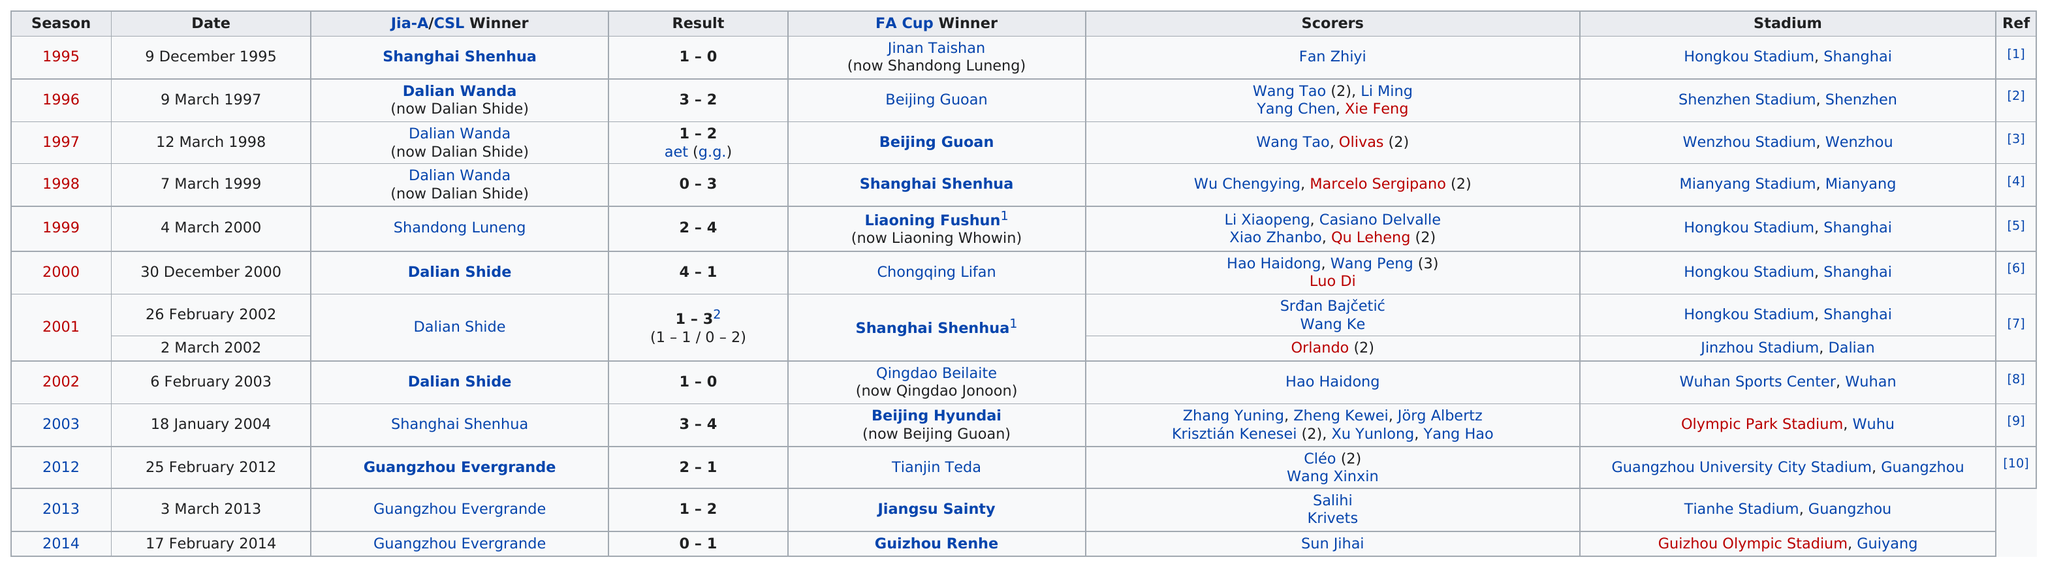Identify some key points in this picture. The match was held at Tianhe Stadium in Guangzhou prior to 2014's match at Guizhou Olympic Stadium. Four people were held at Hongkou Stadium. Wang Peng is the only scorer listed as having scored more than 2 points. How many championship games were held in the same stadium as the one on March 4, 2000? Three. Out of the 1 team, 1 had a total number of goals scored over 6. 